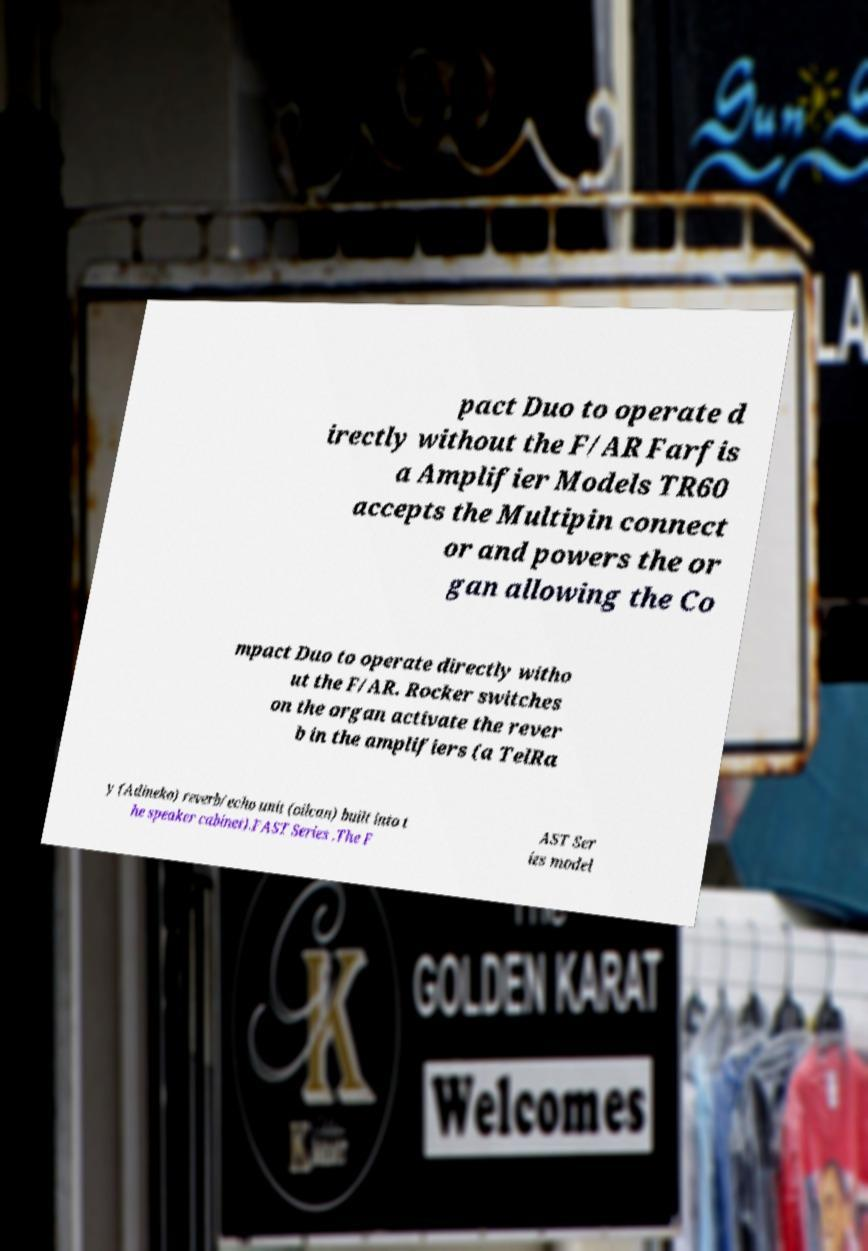Could you assist in decoding the text presented in this image and type it out clearly? pact Duo to operate d irectly without the F/AR Farfis a Amplifier Models TR60 accepts the Multipin connect or and powers the or gan allowing the Co mpact Duo to operate directly witho ut the F/AR. Rocker switches on the organ activate the rever b in the amplifiers (a TelRa y (Adineko) reverb/echo unit (oilcan) built into t he speaker cabinet).FAST Series .The F AST Ser ies model 